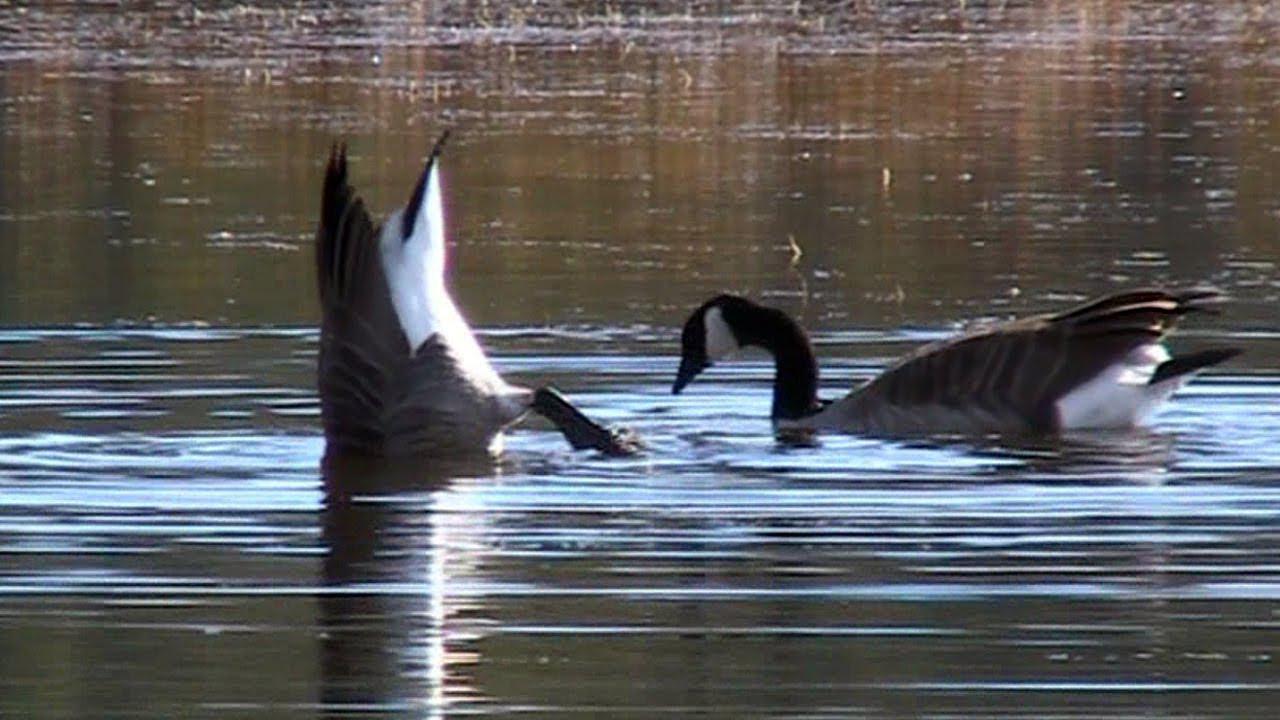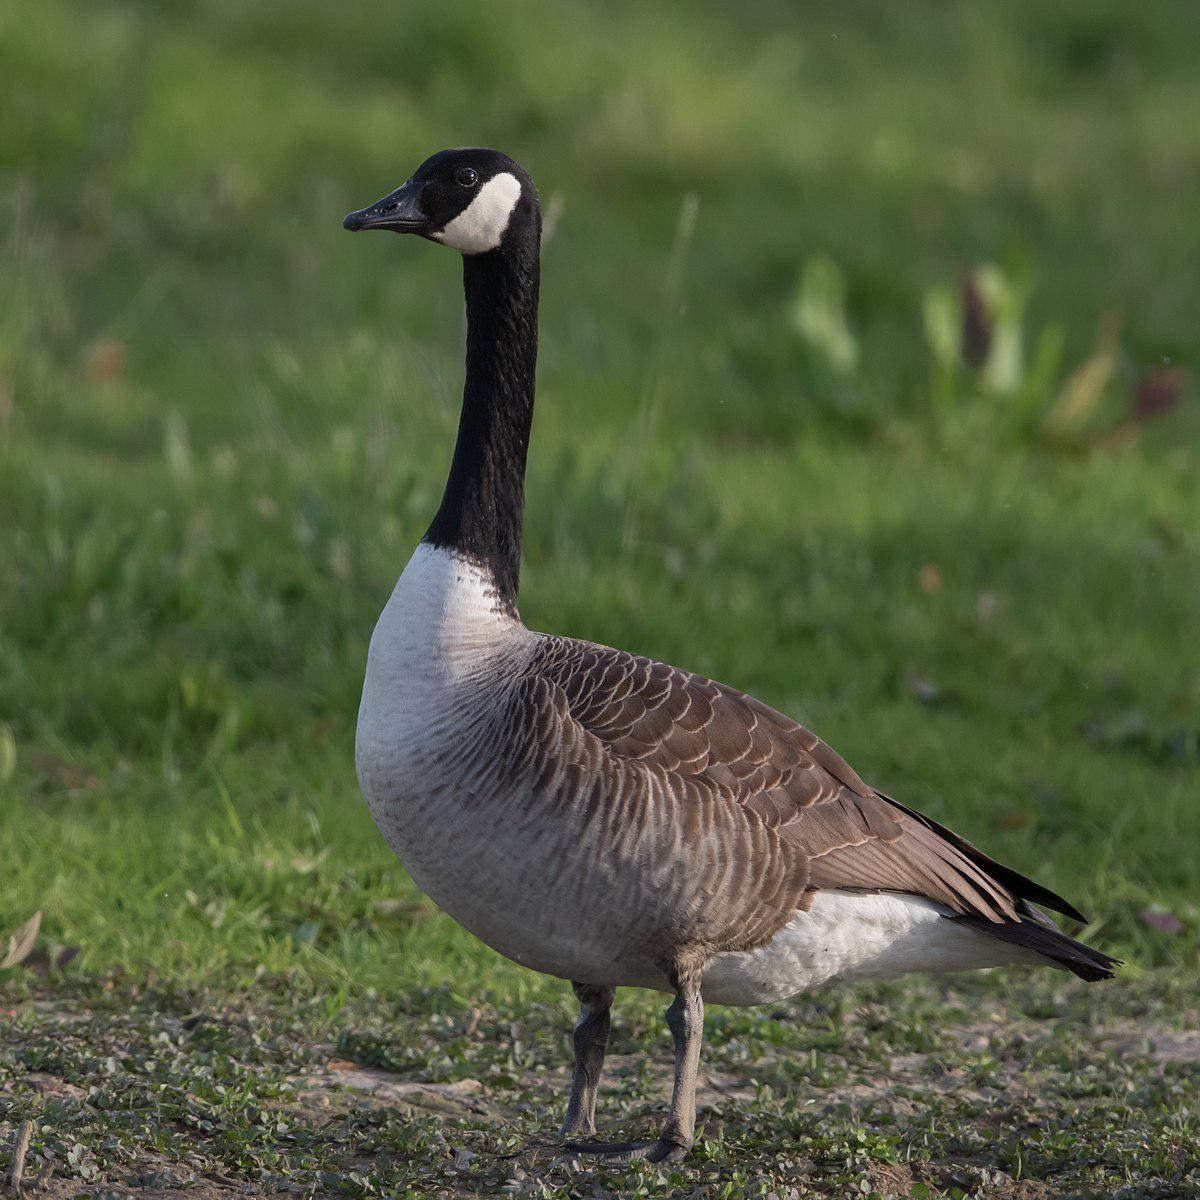The first image is the image on the left, the second image is the image on the right. Analyze the images presented: Is the assertion "No image contains more than two geese, and all geese are standing in grassy areas." valid? Answer yes or no. No. The first image is the image on the left, the second image is the image on the right. Assess this claim about the two images: "The right image contains no more than one goose.". Correct or not? Answer yes or no. Yes. 